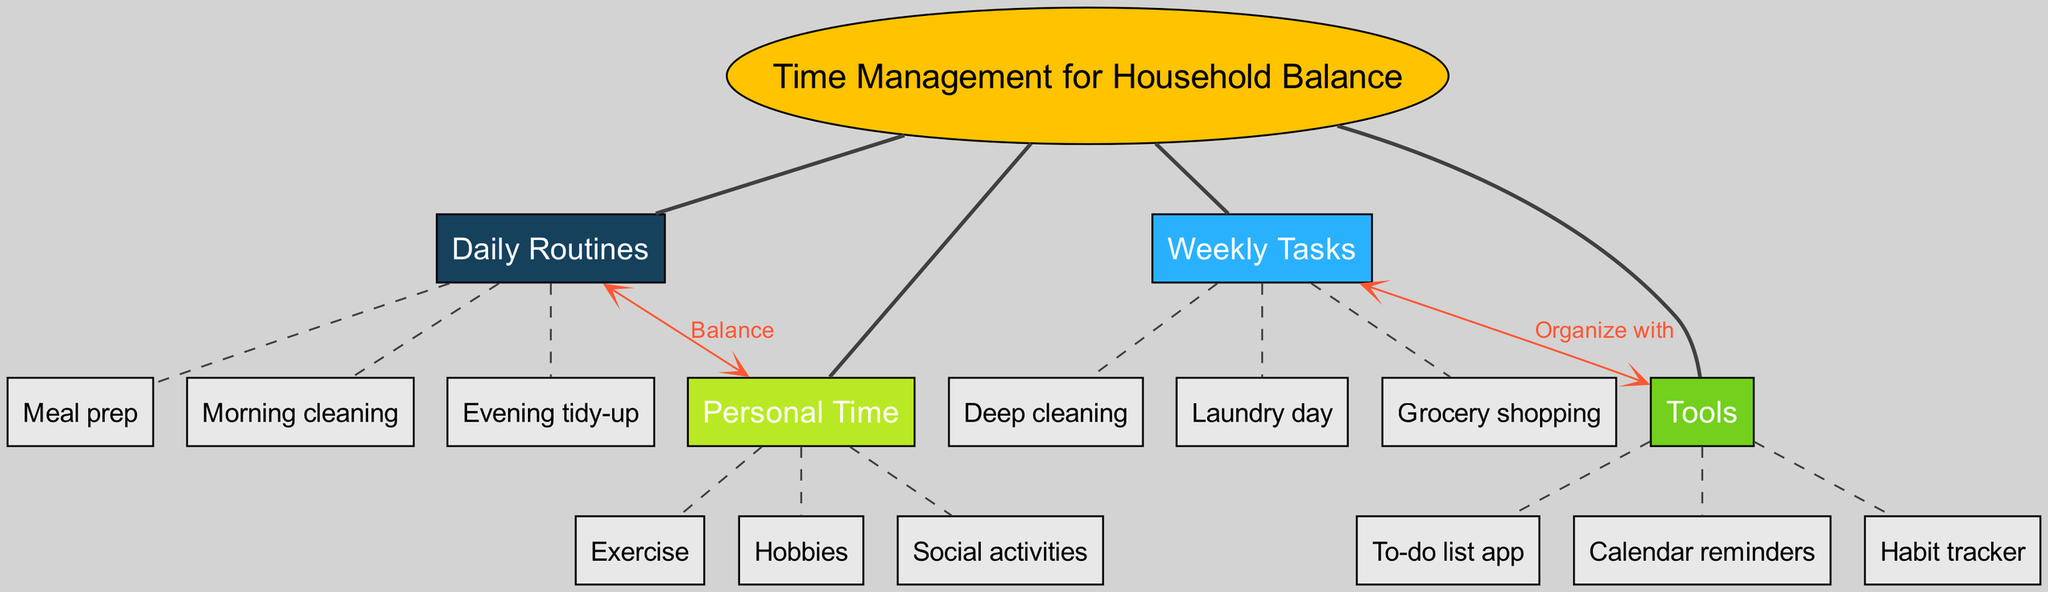What is the central concept of the diagram? The central concept is explicitly labeled in the diagram as "Time Management for Household Balance."
Answer: Time Management for Household Balance How many main branches are there in the diagram? The diagram visually represents four main branches stemming from the central concept.
Answer: 4 What are the sub-branches under the "Weekly Tasks"? The sub-branches listed under "Weekly Tasks" are "Laundry day," "Grocery shopping," and "Deep cleaning."
Answer: Laundry day, Grocery shopping, Deep cleaning Which main branch is connected to "Personal Time"? The diagram shows that "Daily Routines" is connected to "Personal Time" with a label indicating "Balance."
Answer: Daily Routines What do the connections labeled as "Organize with" indicate? The connection labeled "Organize with" indicates that the "Weekly Tasks" are organized or managed with the help of "Tools."
Answer: Tools How many sub-branches does "Daily Routines" have? The "Daily Routines" branch has three sub-branches: "Morning cleaning," "Evening tidy-up," and "Meal prep."
Answer: 3 Which tool is listed under the "Tools" branch? The "To-do list app" is one of the specific tools identified in the "Tools" branch.
Answer: To-do list app How does "Weekly Tasks" relate to "Tools"? The relationship shows that "Weekly Tasks" can be organized with specific "Tools," indicating a supportive function of the tools.
Answer: Organize with What is the color of the central concept node? The central concept node is colored in a distinct "yellow" or similar bright hue, differentiating it from the other branches.
Answer: Yellow 